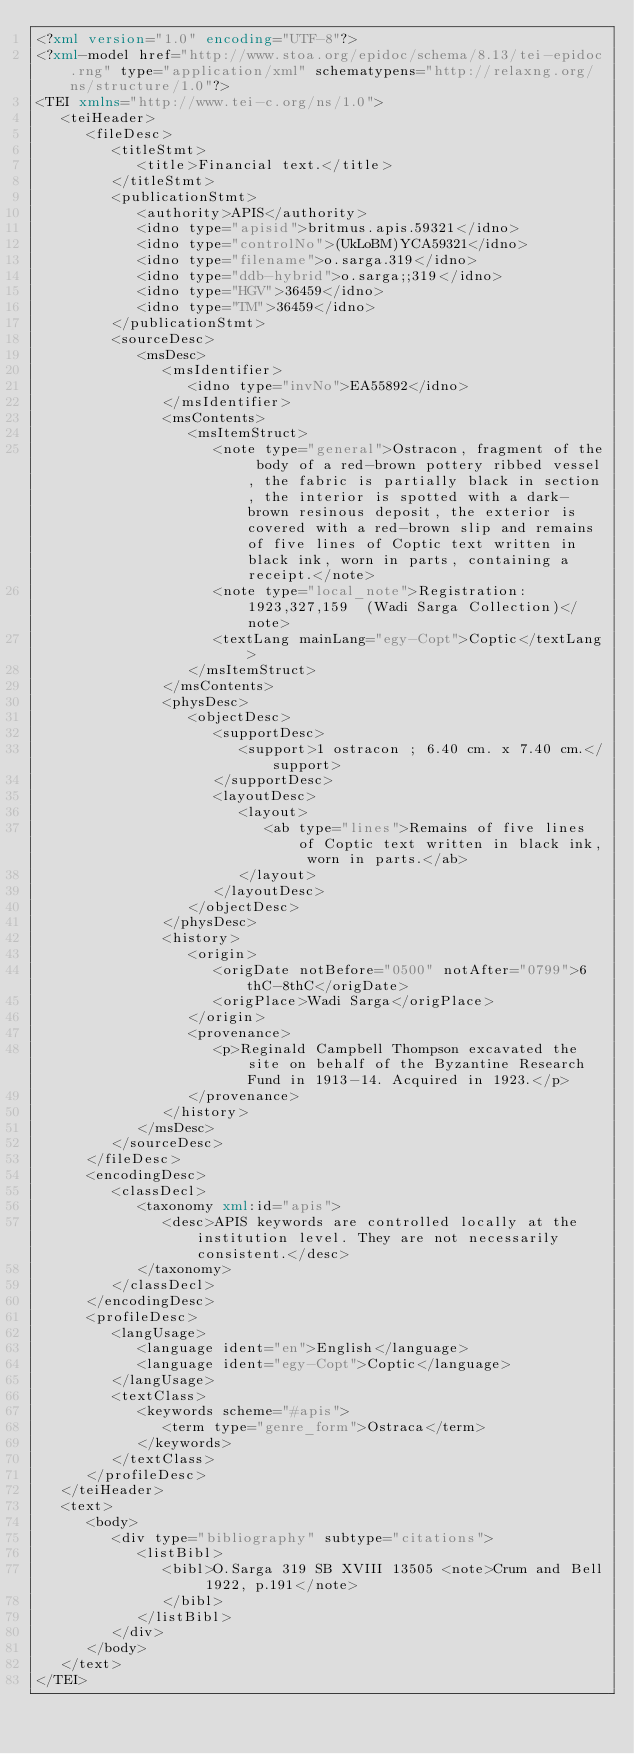<code> <loc_0><loc_0><loc_500><loc_500><_XML_><?xml version="1.0" encoding="UTF-8"?>
<?xml-model href="http://www.stoa.org/epidoc/schema/8.13/tei-epidoc.rng" type="application/xml" schematypens="http://relaxng.org/ns/structure/1.0"?>
<TEI xmlns="http://www.tei-c.org/ns/1.0">
   <teiHeader>
      <fileDesc>
         <titleStmt>
            <title>Financial text.</title>
         </titleStmt>
         <publicationStmt>
            <authority>APIS</authority>
            <idno type="apisid">britmus.apis.59321</idno>
            <idno type="controlNo">(UkLoBM)YCA59321</idno>
            <idno type="filename">o.sarga.319</idno>
            <idno type="ddb-hybrid">o.sarga;;319</idno>
            <idno type="HGV">36459</idno>
            <idno type="TM">36459</idno>
         </publicationStmt>
         <sourceDesc>
            <msDesc>
               <msIdentifier>
                  <idno type="invNo">EA55892</idno>
               </msIdentifier>
               <msContents>
                  <msItemStruct>
                     <note type="general">Ostracon, fragment of the body of a red-brown pottery ribbed vessel, the fabric is partially black in section, the interior is spotted with a dark-brown resinous deposit, the exterior is covered with a red-brown slip and remains of five lines of Coptic text written in black ink, worn in parts, containing a receipt.</note>
                     <note type="local_note">Registration: 1923,327,159  (Wadi Sarga Collection)</note>
                     <textLang mainLang="egy-Copt">Coptic</textLang>
                  </msItemStruct>
               </msContents>
               <physDesc>
                  <objectDesc>
                     <supportDesc>
                        <support>1 ostracon ; 6.40 cm. x 7.40 cm.</support>
                     </supportDesc>
                     <layoutDesc>
                        <layout>
                           <ab type="lines">Remains of five lines of Coptic text written in black ink, worn in parts.</ab>
                        </layout>
                     </layoutDesc>
                  </objectDesc>
               </physDesc>
               <history>
                  <origin>
                     <origDate notBefore="0500" notAfter="0799">6thC-8thC</origDate>
                     <origPlace>Wadi Sarga</origPlace>
                  </origin>
                  <provenance>
                     <p>Reginald Campbell Thompson excavated the site on behalf of the Byzantine Research Fund in 1913-14. Acquired in 1923.</p>
                  </provenance>
               </history>
            </msDesc>
         </sourceDesc>
      </fileDesc>
      <encodingDesc>
         <classDecl>
            <taxonomy xml:id="apis">
               <desc>APIS keywords are controlled locally at the institution level. They are not necessarily consistent.</desc>
            </taxonomy>
         </classDecl>
      </encodingDesc>
      <profileDesc>
         <langUsage>
            <language ident="en">English</language>
            <language ident="egy-Copt">Coptic</language>
         </langUsage>
         <textClass>
            <keywords scheme="#apis">
               <term type="genre_form">Ostraca</term>
            </keywords>
         </textClass>
      </profileDesc>
   </teiHeader>
   <text>
      <body>
         <div type="bibliography" subtype="citations">
            <listBibl>
               <bibl>O.Sarga 319 SB XVIII 13505 <note>Crum and Bell 1922, p.191</note>
               </bibl>
            </listBibl>
         </div>
      </body>
   </text>
</TEI>
</code> 